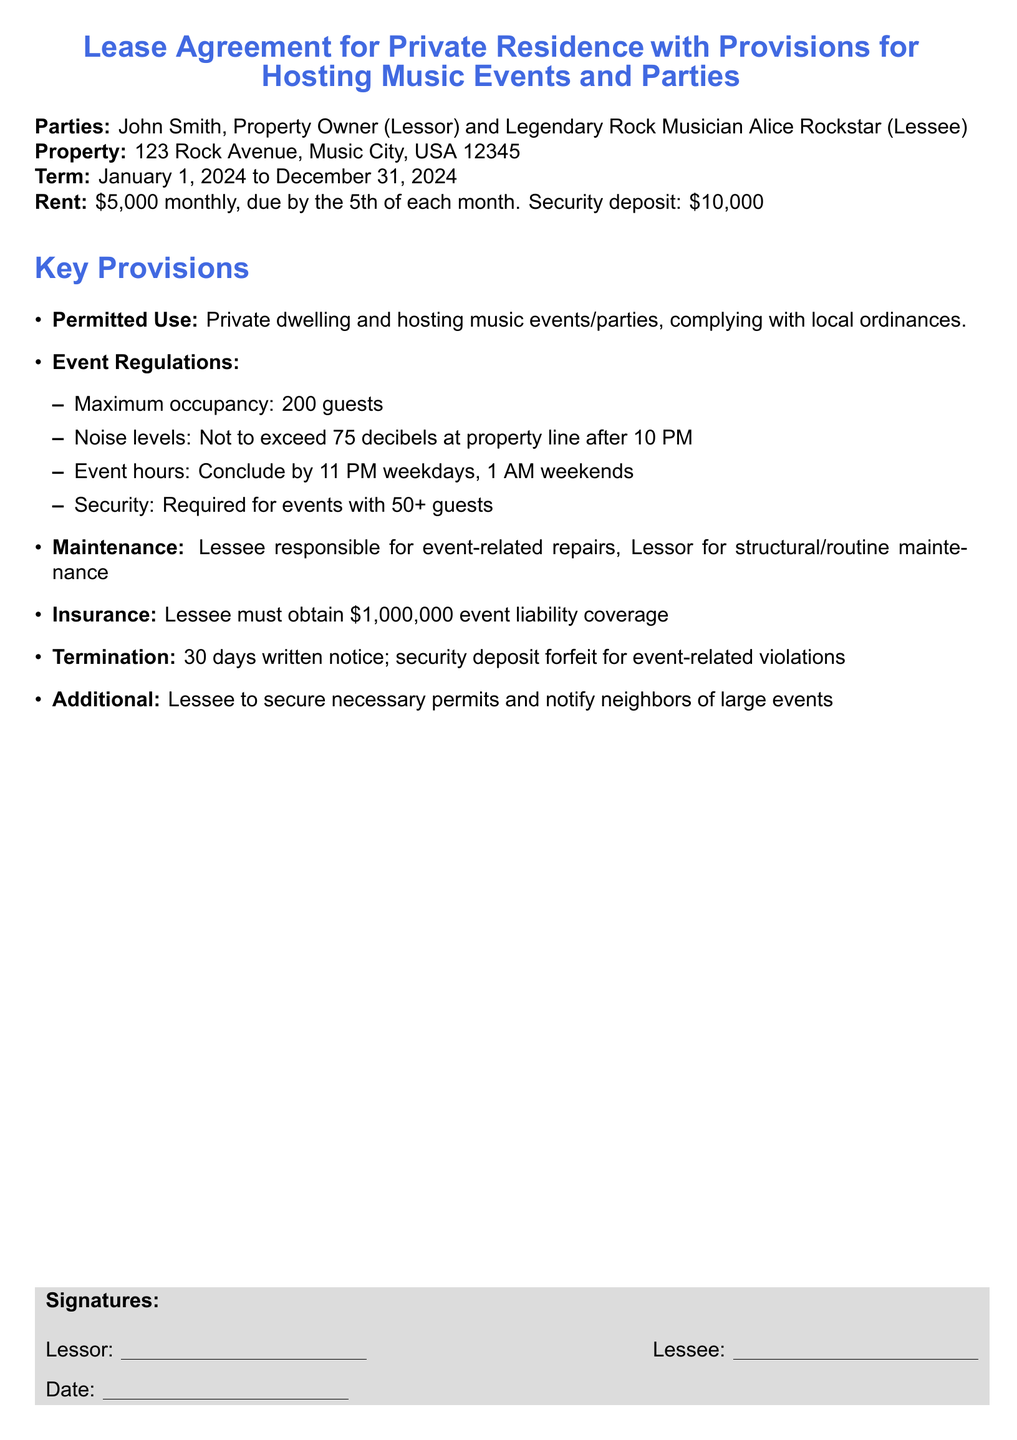What is the property address? The property address is listed in the agreement under the Property section.
Answer: 123 Rock Avenue, Music City, USA 12345 What is the security deposit amount? The security deposit is mentioned in the Rent section of the document.
Answer: \$10,000 What is the maximum number of guests allowed for events? The maximum occupancy is detailed under the Event Regulations section.
Answer: 200 guests What is the required event liability coverage? The required insurance coverage is noted in the Insurance section of the document.
Answer: \$1,000,000 What is the termination notice period? The termination conditions specify the notice required in the Termination section.
Answer: 30 days What are the event hours on weekends? The event hours are specified within the Event Regulations section of the document.
Answer: 1 AM What is the monthly rent amount? The Rent section of the document specifies the monthly rent amount.
Answer: \$5,000 Who is the lessor? The lessor is identified at the beginning of the document.
Answer: John Smith What is the lessee's name? The lessee's name is stated right after the lessor's name in the introduction.
Answer: Alice Rockstar 